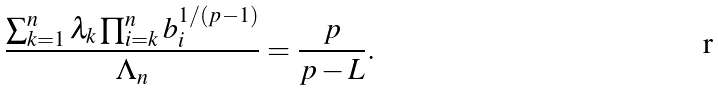<formula> <loc_0><loc_0><loc_500><loc_500>\frac { \sum ^ { n } _ { k = 1 } \lambda _ { k } \prod ^ { n } _ { i = k } b ^ { 1 / ( p - 1 ) } _ { i } } { \Lambda _ { n } } = \frac { p } { p - L } .</formula> 